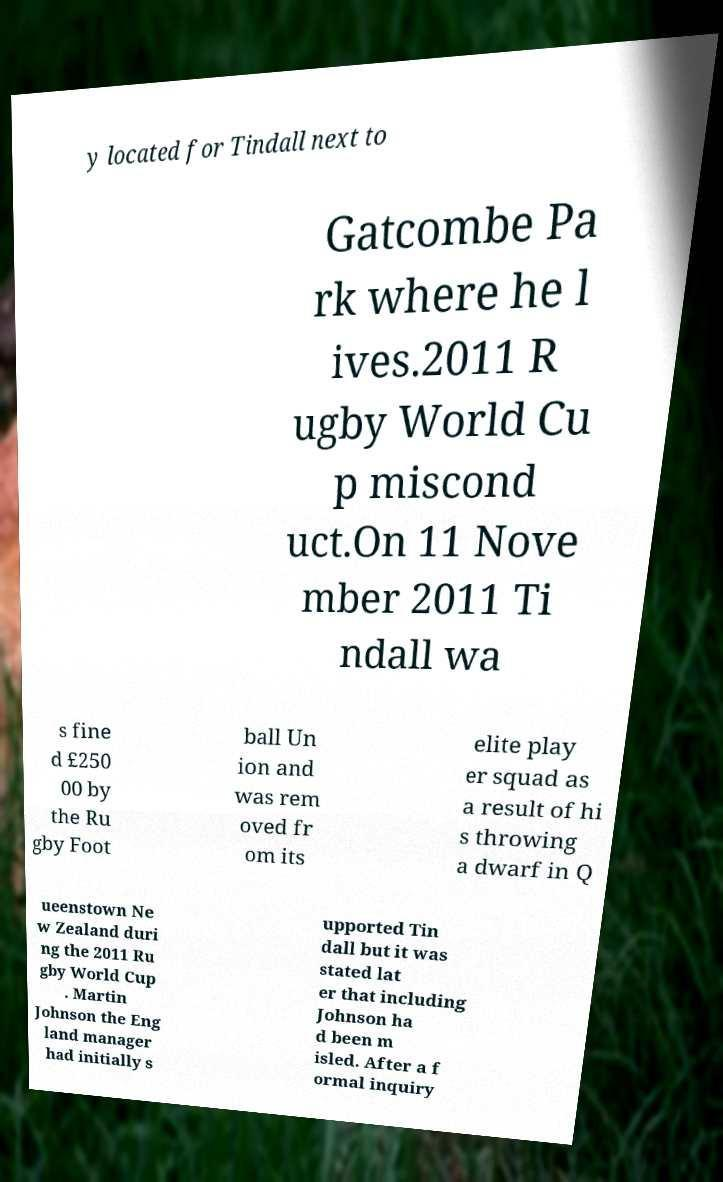What messages or text are displayed in this image? I need them in a readable, typed format. y located for Tindall next to Gatcombe Pa rk where he l ives.2011 R ugby World Cu p miscond uct.On 11 Nove mber 2011 Ti ndall wa s fine d £250 00 by the Ru gby Foot ball Un ion and was rem oved fr om its elite play er squad as a result of hi s throwing a dwarf in Q ueenstown Ne w Zealand duri ng the 2011 Ru gby World Cup . Martin Johnson the Eng land manager had initially s upported Tin dall but it was stated lat er that including Johnson ha d been m isled. After a f ormal inquiry 